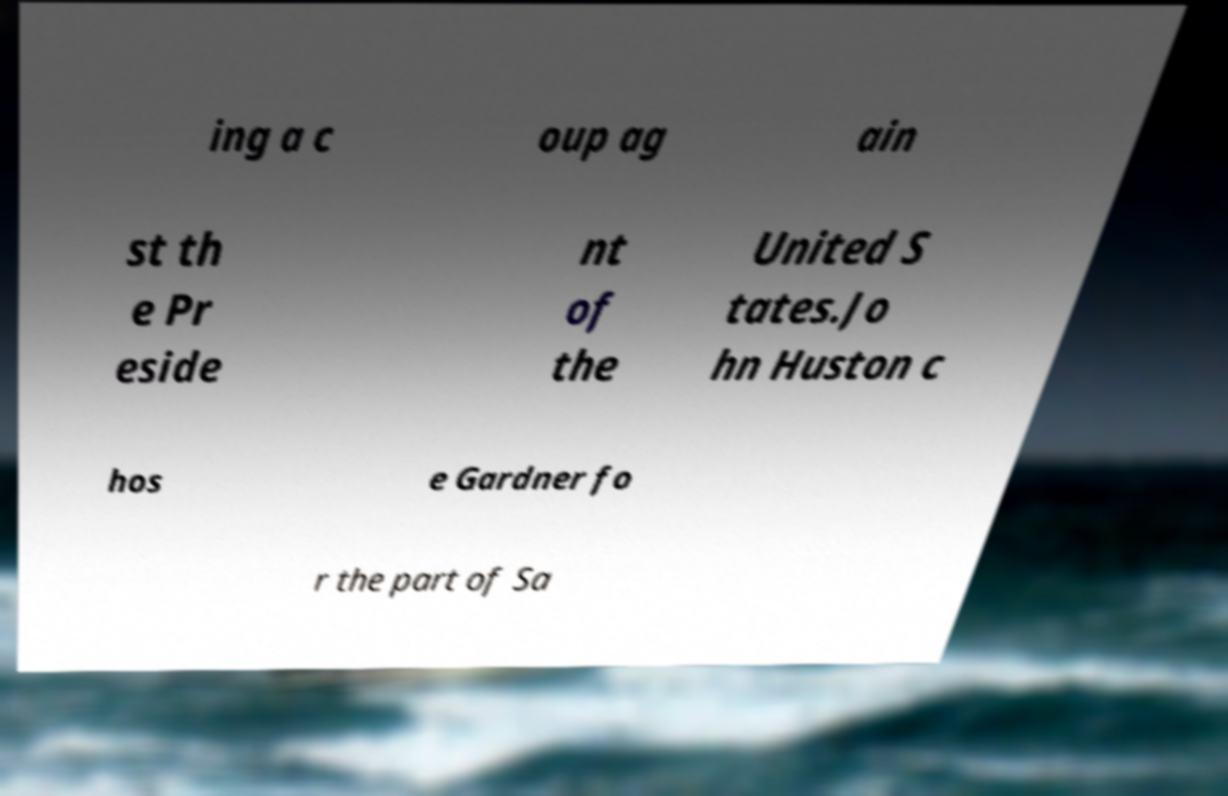There's text embedded in this image that I need extracted. Can you transcribe it verbatim? ing a c oup ag ain st th e Pr eside nt of the United S tates.Jo hn Huston c hos e Gardner fo r the part of Sa 